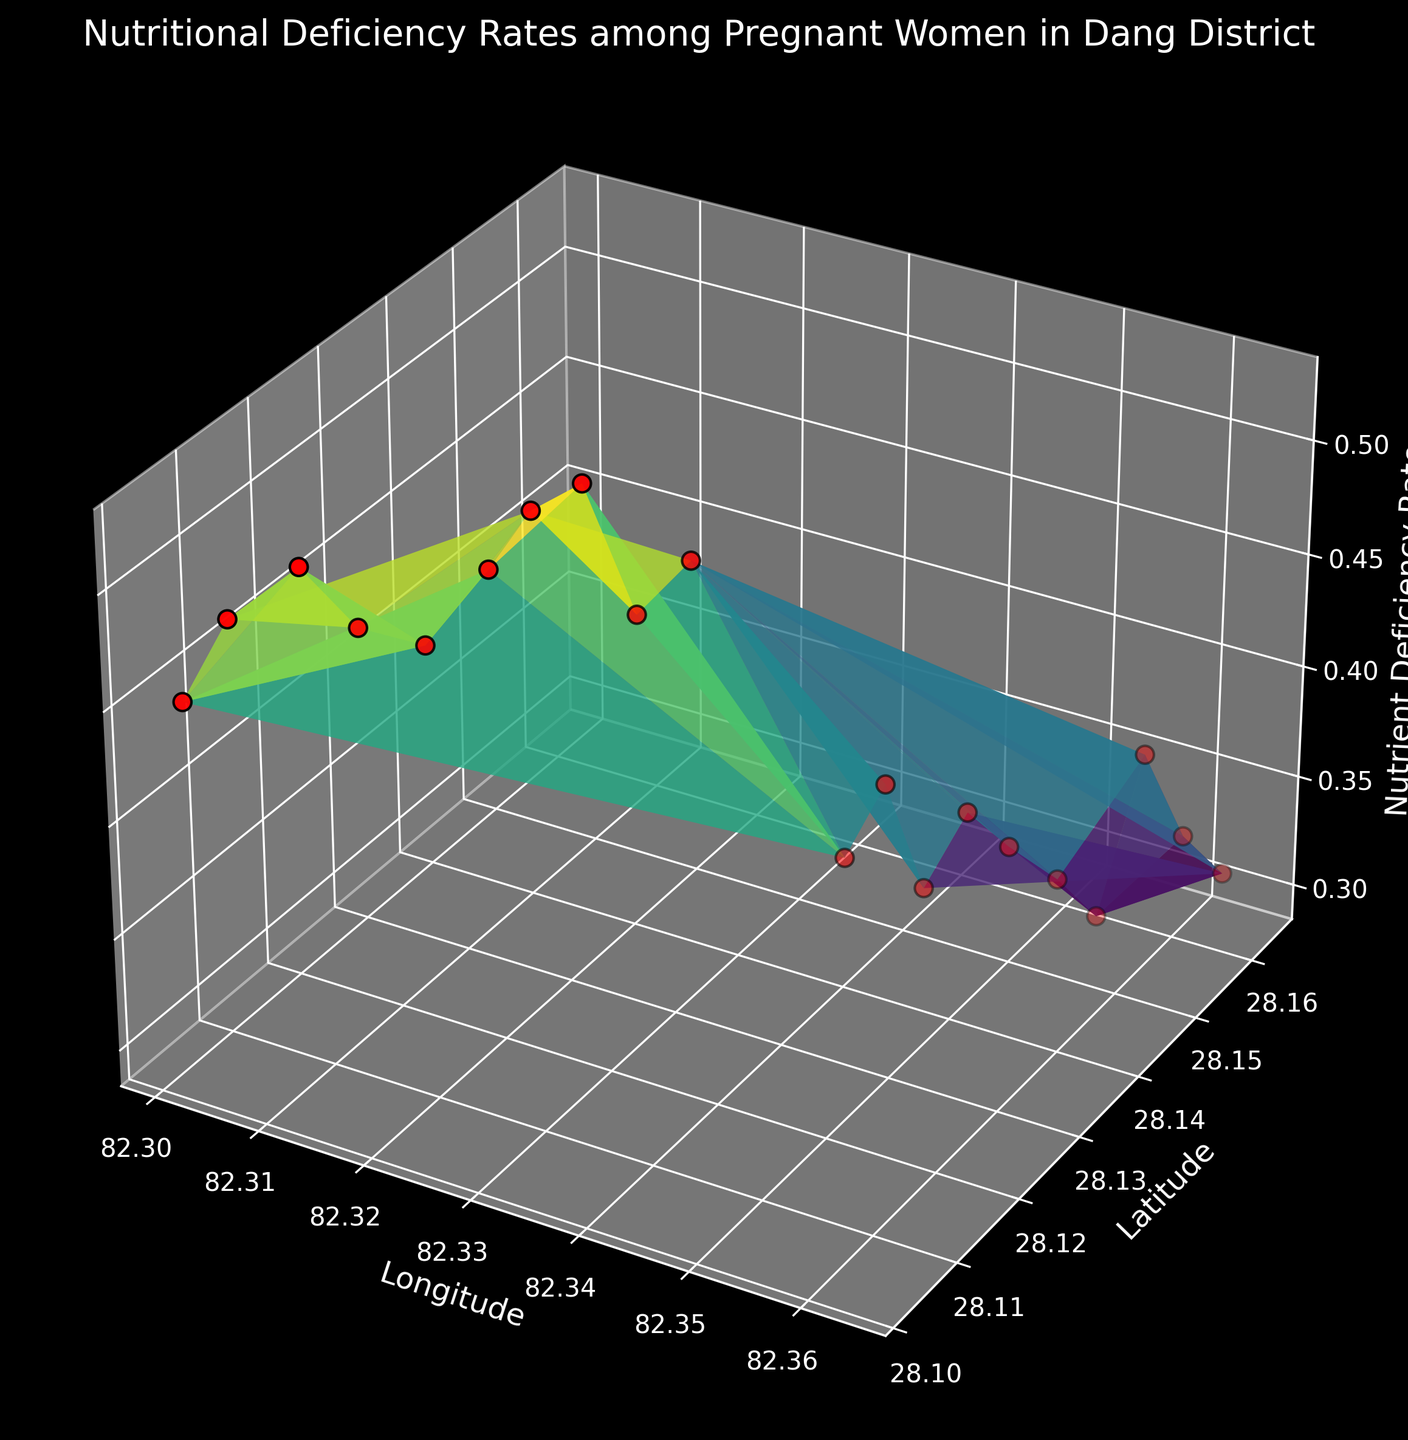What can be observed about the nutrient deficiency rates between rural and urban areas? The surface plot shows that the nutrient deficiency rates in rural areas tend to be higher compared to urban areas. This can be observed by noting the height difference between the regions representing rural (higher elevation) and urban (lower elevation) areas on the plot.
Answer: Rural areas have higher nutrient deficiency rates Between which latitudes do the rural areas span? The rural areas in the plot span from approximately latitude 28.1032 to 28.1324, as seen from the data points labeled as 'Rural'.
Answer: 28.1032 to 28.1324 Which urban area has the highest nutrient deficiency rate and what is its value? By looking at the peak points within the urban area data range, Urban8 (latitude 28.1580, longitude 82.3580) has the highest peak in height which corresponds to the nutrient deficiency rate of 0.37.
Answer: Urban8 with 0.37 How does the nutrient deficiency rate change as we move from Urban1 to Urban10? Observing the height of the surface and scatter points from Urban1 to Urban10, the nutrient deficiency rate generally decreases, indicated by shorter heights in the surface plot toward Urban10.
Answer: It decreases What is the average nutrient deficiency rate for the rural areas? To find the average nutrient deficiency rate for rural areas, sum the rates (0.45 + 0.48 + 0.50 + 0.47 + 0.46 + 0.49 + 0.51 + 0.52 + 0.46 + 0.48) = 4.82, then divide by the number of rural areas, 10: 4.82 / 10 = 0.482.
Answer: 0.482 Where can the lowest nutrient deficiency rate in urban areas be found? The lowest visual height for urban areas is at Urban7 (latitude 28.1550, longitude 82.3555), where the nutrient deficiency rate is 0.30.
Answer: Urban7, 0.30 Is there more variation in nutrient deficiency rates in rural or urban areas? By visually inspecting the height variations, rural areas exhibit greater height differences compared to urban areas, indicating greater variation in nutrient deficiency rates.
Answer: Rural areas have more variation Which rural area has the lowest nutrient deficiency rate? The lowest point by height within the rural area data range is at Rural1 (latitude 28.1032, longitude 82.3012) where the nutrient deficiency rate is 0.45.
Answer: Rural1, 0.45 What is the difference between the highest and lowest nutrient deficiency rates in the rural area? The highest rate in the rural area is 0.52 (Rural8) and the lowest is 0.45 (Rural1), so the difference is 0.52 - 0.45 = 0.07.
Answer: 0.07 How does the nutrient deficiency rate for Urban4 compare to Rural4? Comparing the heights of both points, Rural4 (latitude 28.1136, longitude 82.3109) is higher (0.47) than Urban4 (latitude 28.1460, longitude 82.3481) which is at 0.36.
Answer: Rural4 is higher 